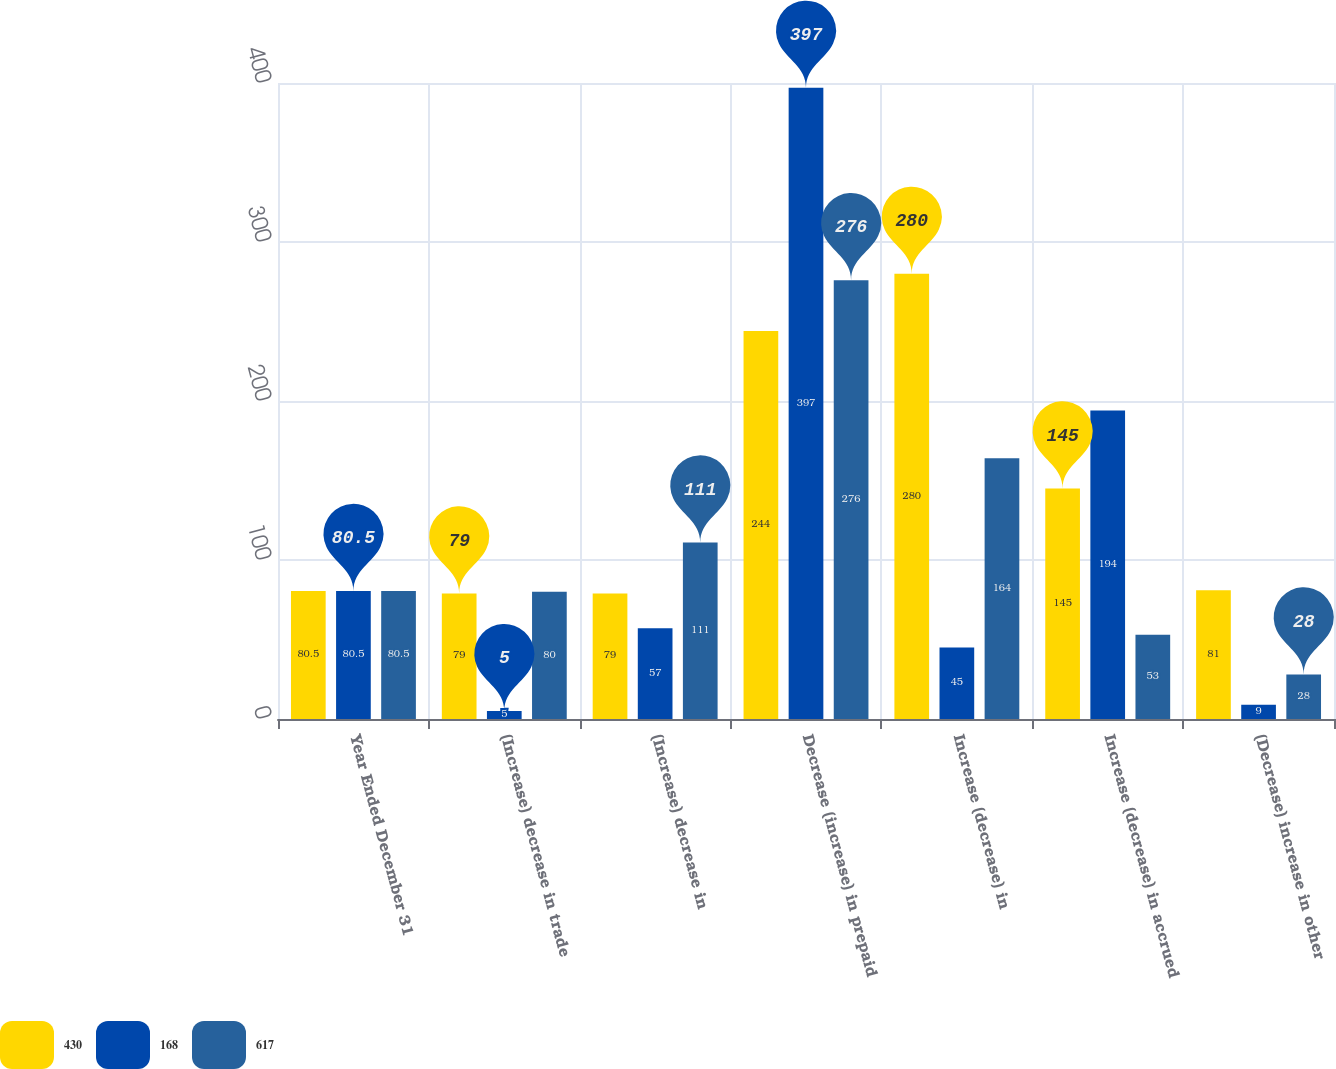<chart> <loc_0><loc_0><loc_500><loc_500><stacked_bar_chart><ecel><fcel>Year Ended December 31<fcel>(Increase) decrease in trade<fcel>(Increase) decrease in<fcel>Decrease (increase) in prepaid<fcel>Increase (decrease) in<fcel>Increase (decrease) in accrued<fcel>(Decrease) increase in other<nl><fcel>430<fcel>80.5<fcel>79<fcel>79<fcel>244<fcel>280<fcel>145<fcel>81<nl><fcel>168<fcel>80.5<fcel>5<fcel>57<fcel>397<fcel>45<fcel>194<fcel>9<nl><fcel>617<fcel>80.5<fcel>80<fcel>111<fcel>276<fcel>164<fcel>53<fcel>28<nl></chart> 